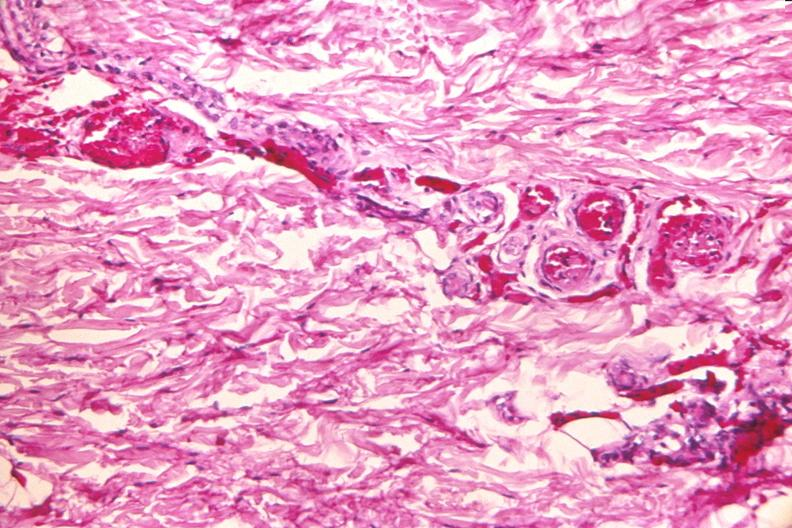where is this?
Answer the question using a single word or phrase. Skin 